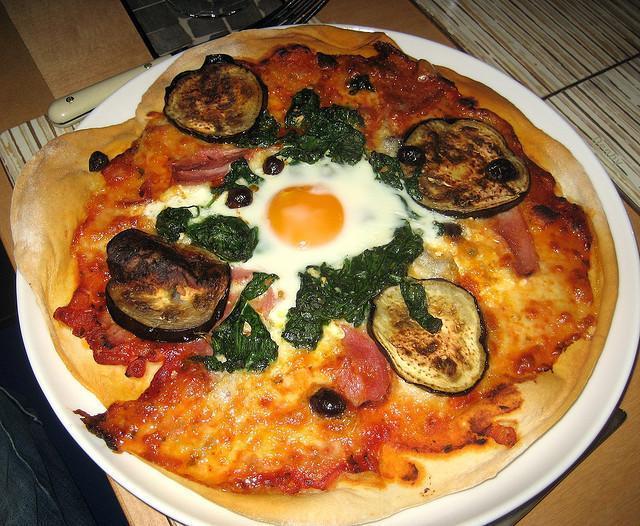How many people are in the photo?
Give a very brief answer. 0. 